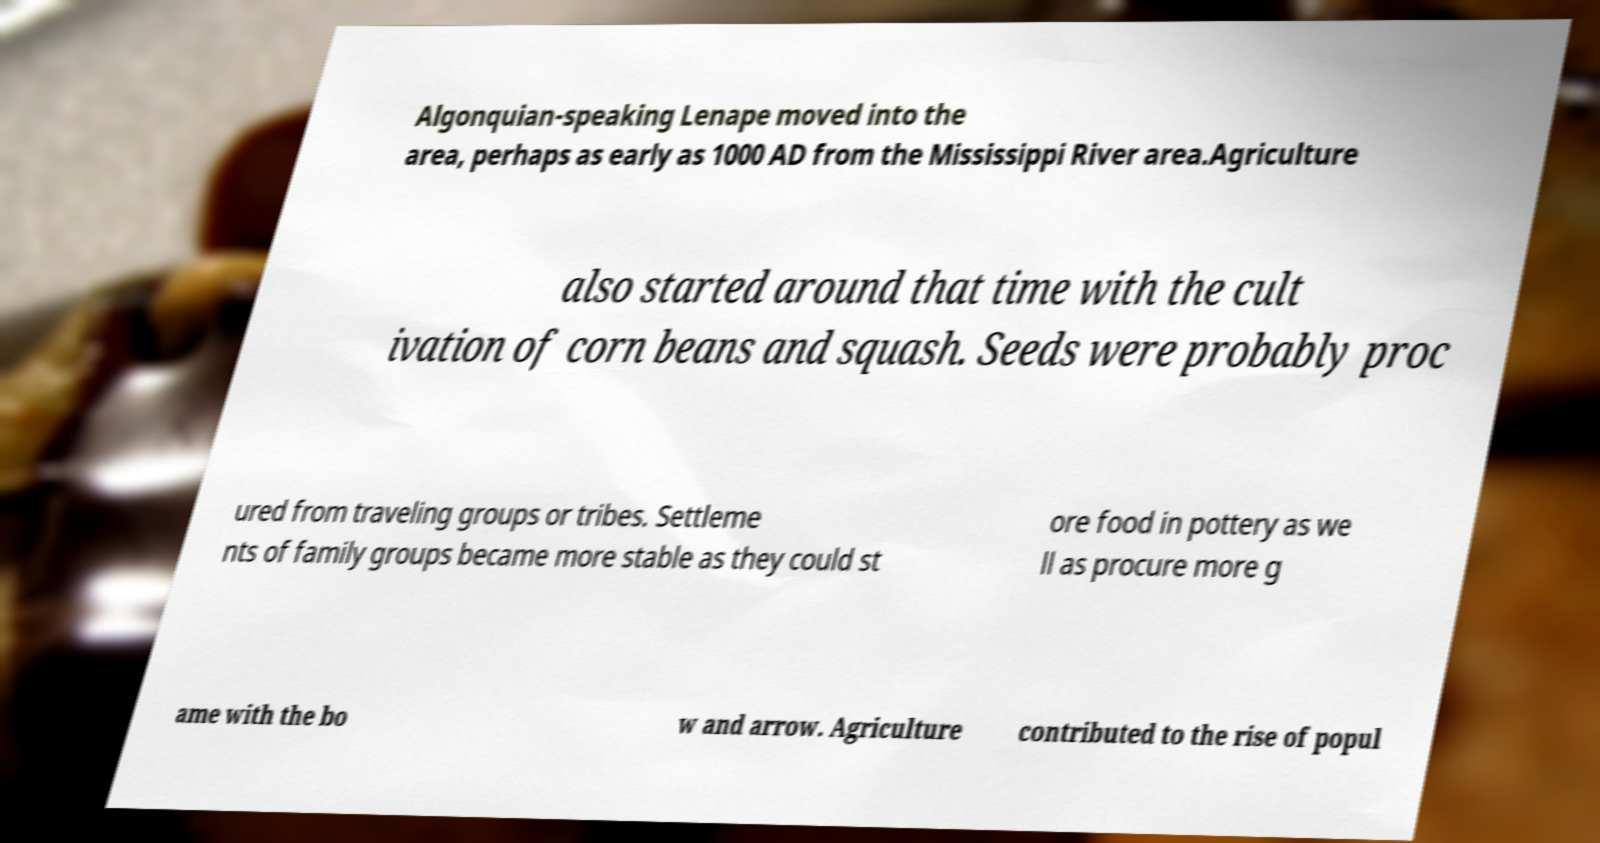Could you assist in decoding the text presented in this image and type it out clearly? Algonquian-speaking Lenape moved into the area, perhaps as early as 1000 AD from the Mississippi River area.Agriculture also started around that time with the cult ivation of corn beans and squash. Seeds were probably proc ured from traveling groups or tribes. Settleme nts of family groups became more stable as they could st ore food in pottery as we ll as procure more g ame with the bo w and arrow. Agriculture contributed to the rise of popul 